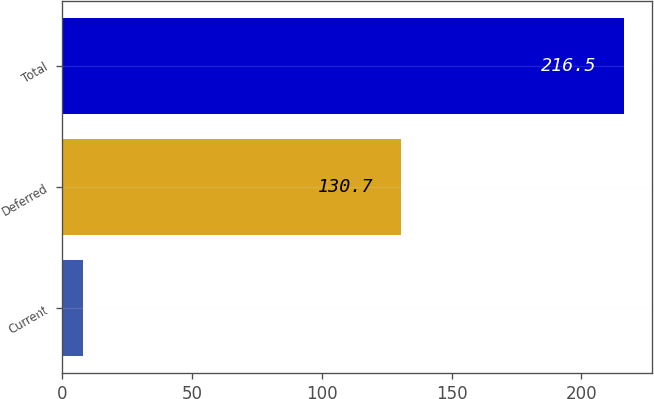Convert chart to OTSL. <chart><loc_0><loc_0><loc_500><loc_500><bar_chart><fcel>Current<fcel>Deferred<fcel>Total<nl><fcel>8<fcel>130.7<fcel>216.5<nl></chart> 